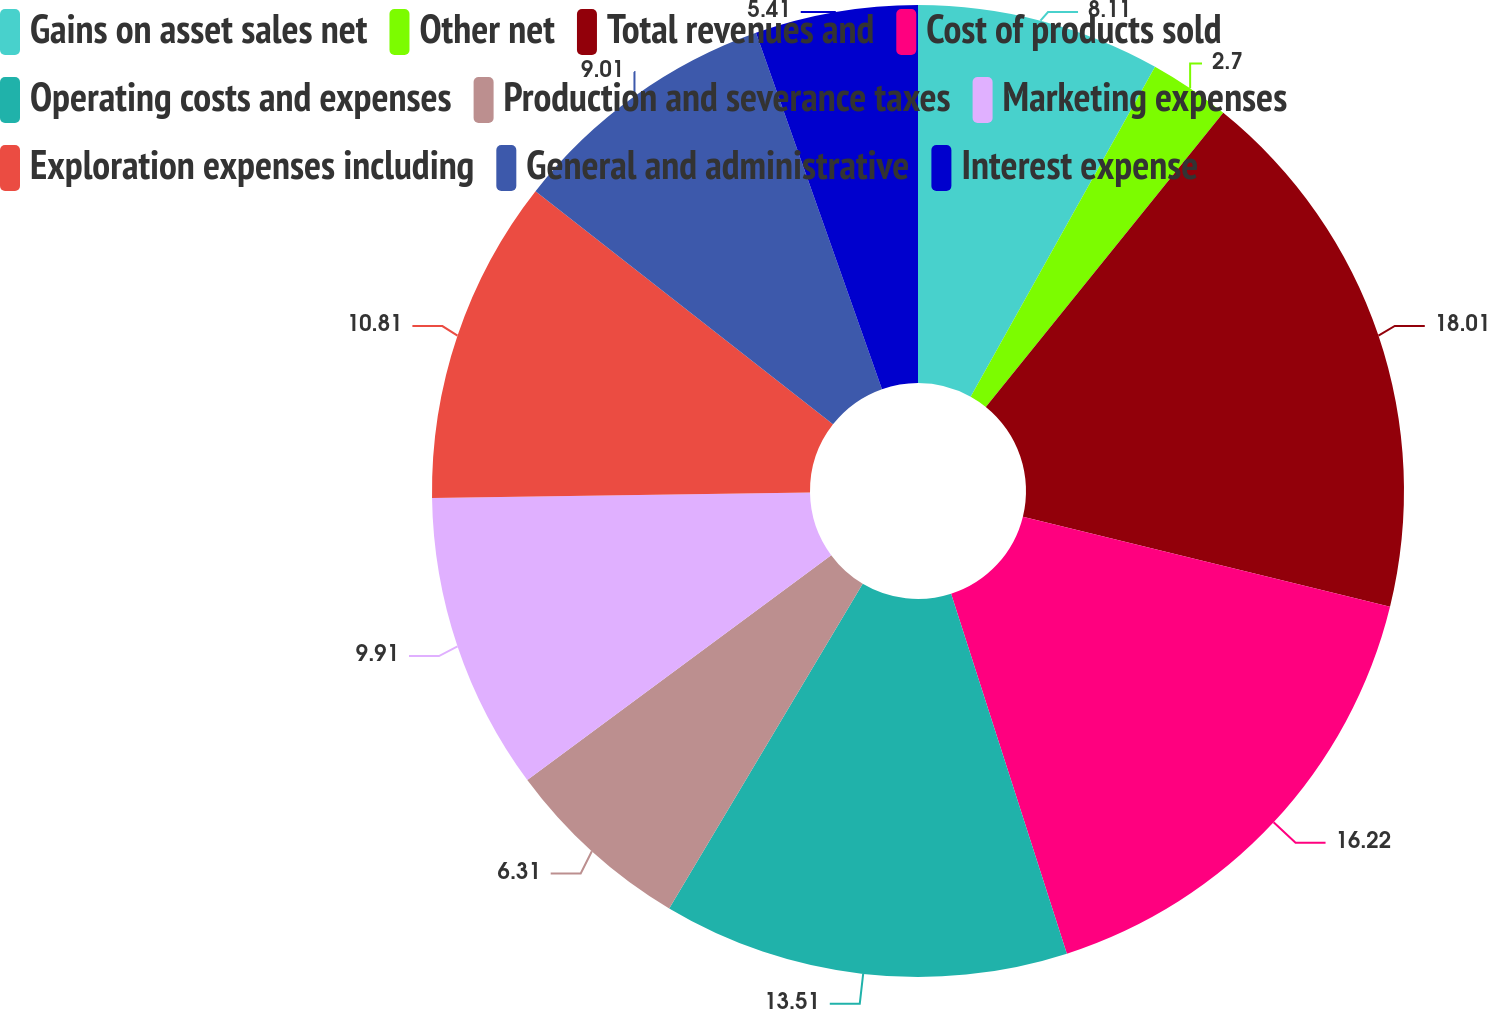Convert chart. <chart><loc_0><loc_0><loc_500><loc_500><pie_chart><fcel>Gains on asset sales net<fcel>Other net<fcel>Total revenues and<fcel>Cost of products sold<fcel>Operating costs and expenses<fcel>Production and severance taxes<fcel>Marketing expenses<fcel>Exploration expenses including<fcel>General and administrative<fcel>Interest expense<nl><fcel>8.11%<fcel>2.7%<fcel>18.02%<fcel>16.22%<fcel>13.51%<fcel>6.31%<fcel>9.91%<fcel>10.81%<fcel>9.01%<fcel>5.41%<nl></chart> 